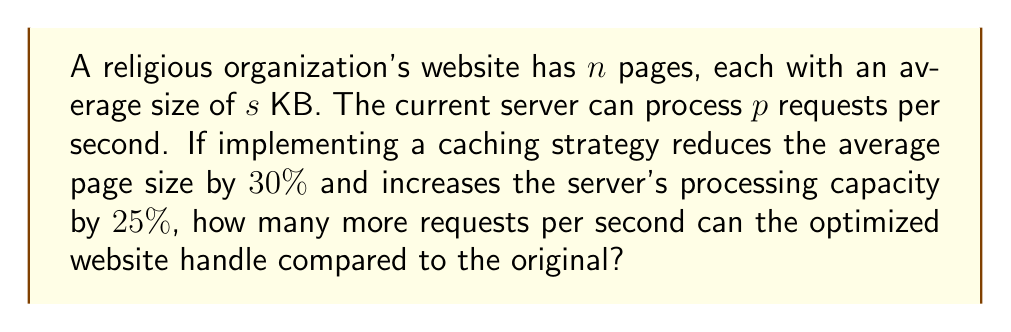Can you answer this question? Let's approach this step-by-step:

1) First, let's calculate the original website's capacity:
   - Original capacity = $p$ requests/second

2) Now, let's calculate the new page size after caching:
   - New page size = $s - (30\% \times s) = 0.7s$ KB

3) The server's processing capacity increases by 25%:
   - New processing capacity = $p + (25\% \times p) = 1.25p$ requests/second

4) To find how many more requests can be handled, we subtract the original capacity from the new capacity:
   $$\text{Additional requests} = 1.25p - p = 0.25p$$

5) Therefore, the optimized website can handle $0.25p$ more requests per second compared to the original.
Answer: $0.25p$ requests/second 